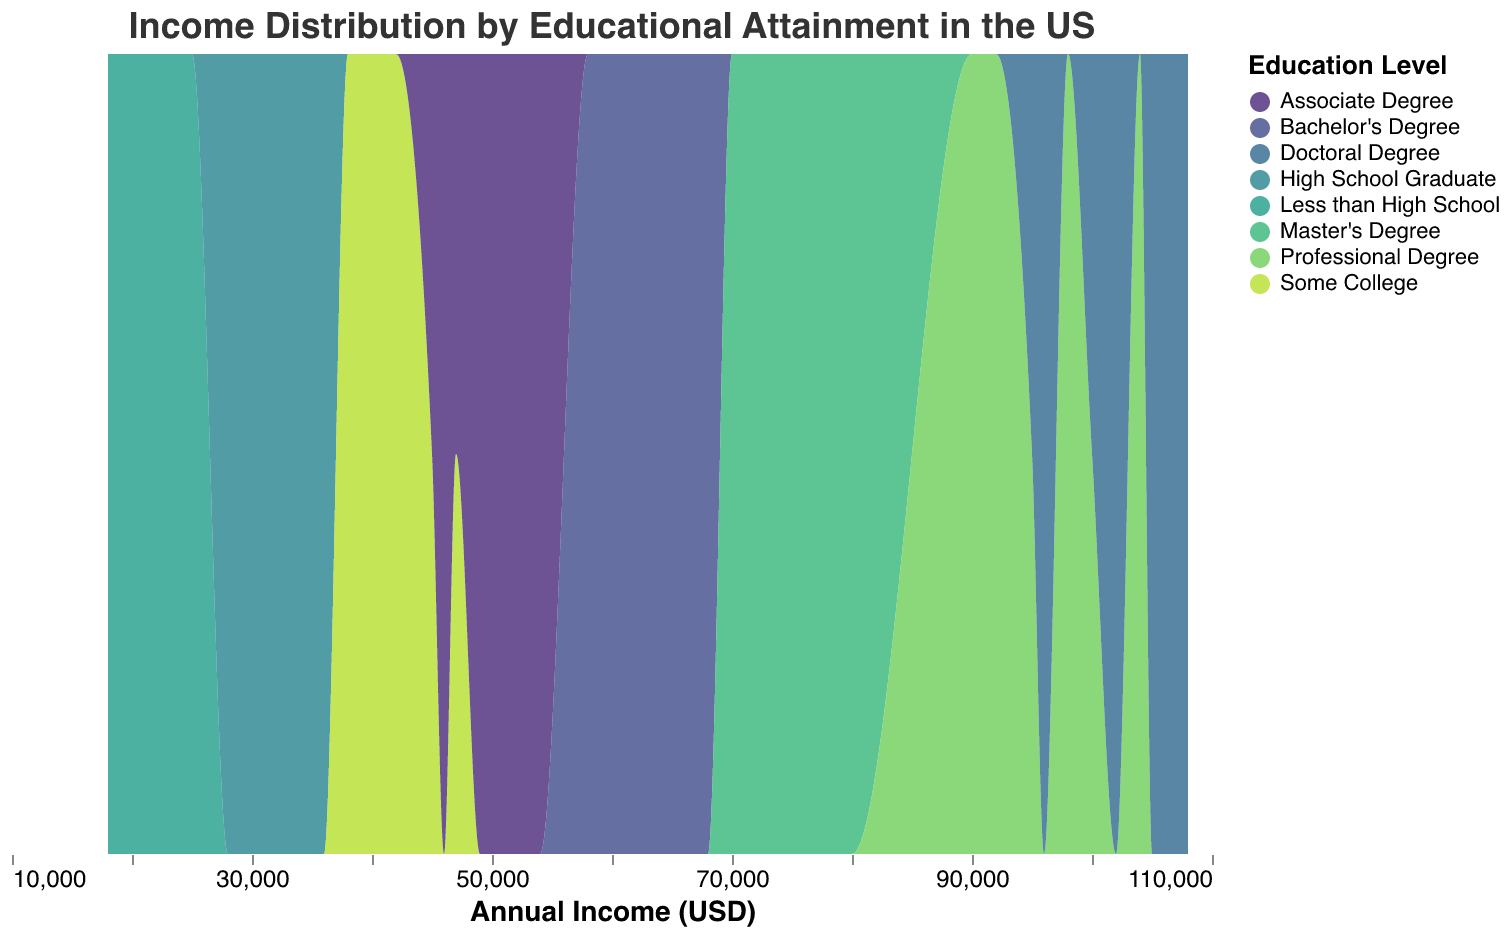What is the title of the figure? The title is displayed prominently at the top of the figure within the title field. It summarizes the central topic of the figure.
Answer: Income Distribution by Educational Attainment in the US What does the x-axis represent? The labels and title on the x-axis provide information about what this axis measures, which is indicated as "Annual Income (USD)".
Answer: Annual Income (USD) What is the highest income level represented in the plot? By analyzing the farthest right point on the x-axis, you can identify the highest income level, which is represented by the last tick on the axis.
Answer: 108,000 Which education level has the highest median income? For this, you need to find the middle point of each education level's distribution and compare them. Professional Degree and Doctoral Degree have the highest and are very close, but Doctoral Degree goes slightly higher in distribution.
Answer: Doctoral Degree Which education level shows the widest distribution in income? To determine this, observe which statistical distribution spans the largest range on the x-axis. Visual inspection reveals that Professional Degree spans from 90,000 to 104,000.
Answer: Professional Degree What are the income ranges for High School Graduates? The bounds of the distribution area for High School Graduate on the x-axis indicate the income range.
Answer: 28,000 to 36,000 Which education level starts with an income of approximately 45,000 USD? By identifying the starting point of each distribution, you can see that some College and Associate Degree both start near this value, with Associate Degree starting almost exactly at 45,000.
Answer: Associate Degree What is the common trend observed as educational attainment increases from Less than High School to Doctoral Degree? By examining the overall shift in the distribution areas horizontally from left to right, you can see that higher educational levels tend to correlate with higher income ranges.
Answer: Higher education levels correlate with higher income What income level do people with a Master’s Degree typically fall into? The central tendency of the distribution for the Master’s Degree category gives insight into where most individuals with this degree fall in terms of income, which centers around 70,000 to 80,000 USD.
Answer: 70,000 to 80,000 USD How does the bachelor's degree income distribution compare with an associate degree? Look at the relative position and spread of the Bachelor's Degree and Associate Degree distributions on the x-axis. The Bachelor's Degree distribution is consistently higher and wider, starting around 58,000 and going up to 68,000.
Answer: Higher and wider for Bachelor's Degree 